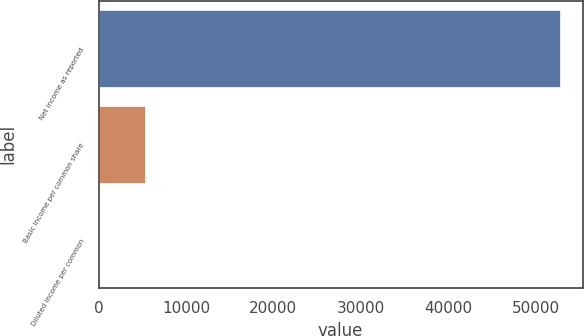Convert chart. <chart><loc_0><loc_0><loc_500><loc_500><bar_chart><fcel>Net income as reported<fcel>Basic income per common share<fcel>Diluted income per common<nl><fcel>52773<fcel>5277.76<fcel>0.51<nl></chart> 